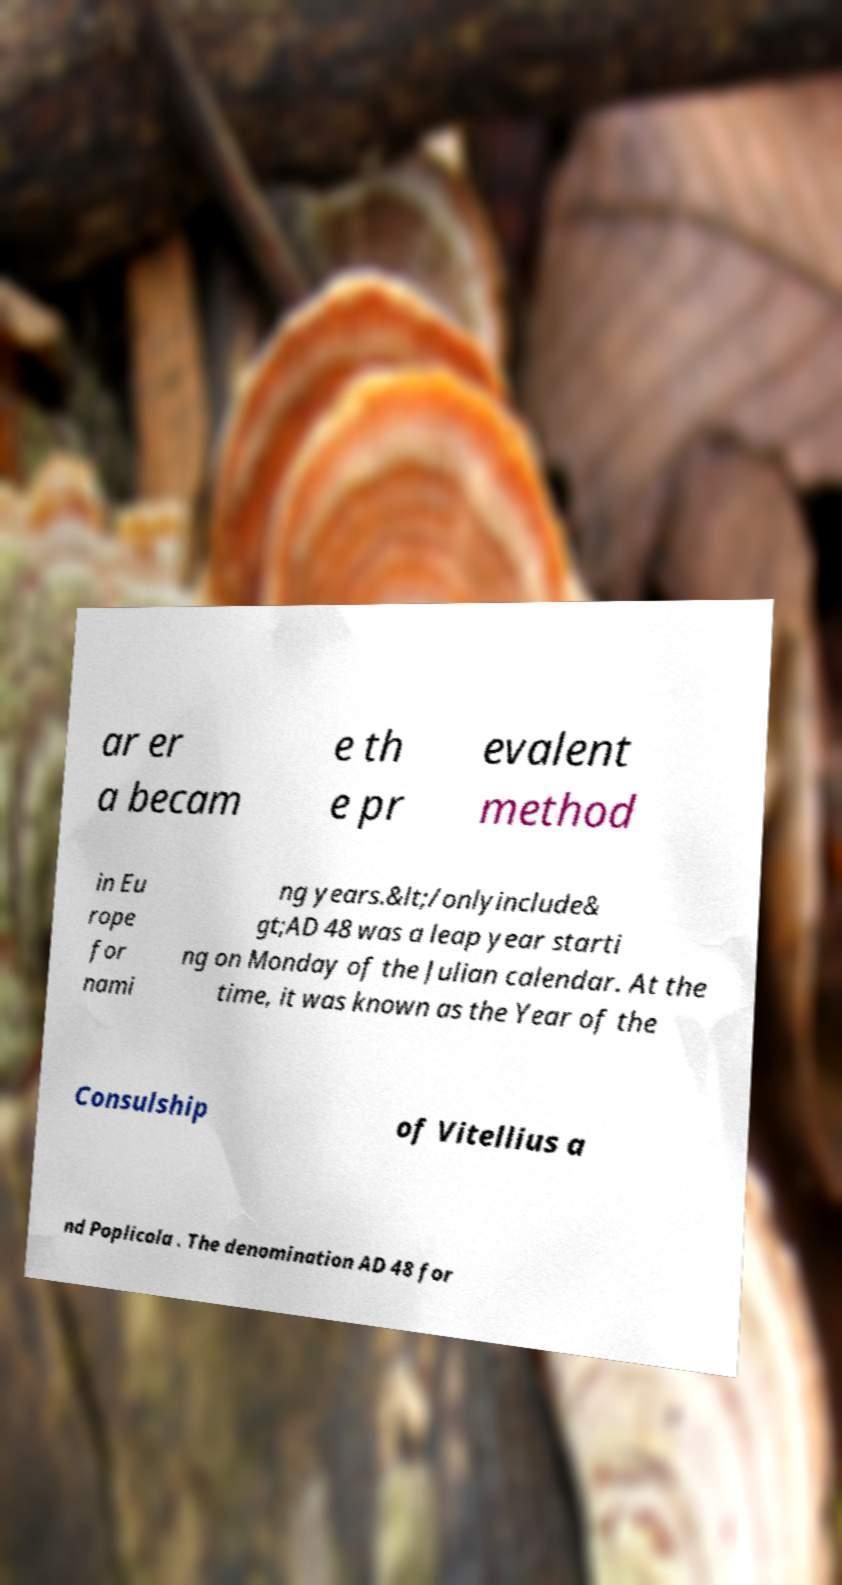Can you accurately transcribe the text from the provided image for me? ar er a becam e th e pr evalent method in Eu rope for nami ng years.&lt;/onlyinclude& gt;AD 48 was a leap year starti ng on Monday of the Julian calendar. At the time, it was known as the Year of the Consulship of Vitellius a nd Poplicola . The denomination AD 48 for 